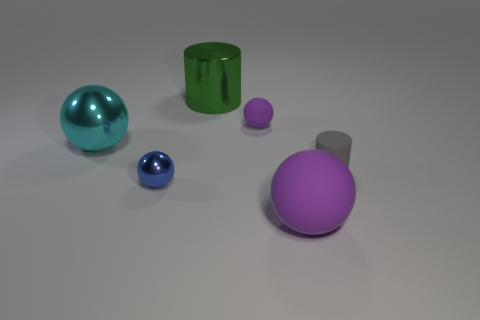How many large green objects are behind the rubber sphere left of the large object to the right of the large green cylinder?
Offer a terse response. 1. Is the number of cyan shiny objects that are to the right of the small gray thing less than the number of tiny gray objects that are to the right of the big green metal thing?
Provide a short and direct response. Yes. There is a blue object that is the same size as the gray rubber cylinder; what material is it?
Keep it short and to the point. Metal. What number of cyan objects are either large objects or balls?
Offer a terse response. 1. There is a small thing that is in front of the large cyan object and right of the blue object; what color is it?
Your answer should be very brief. Gray. Do the purple object to the left of the large matte thing and the large thing that is in front of the small blue metal object have the same material?
Your answer should be very brief. Yes. Are there more metallic cylinders that are in front of the large purple object than big cyan things that are right of the large metal sphere?
Ensure brevity in your answer.  No. There is a purple object that is the same size as the blue object; what shape is it?
Your answer should be very brief. Sphere. How many things are big cylinders or big shiny things right of the blue sphere?
Make the answer very short. 1. Is the tiny metal thing the same color as the tiny rubber ball?
Offer a terse response. No. 